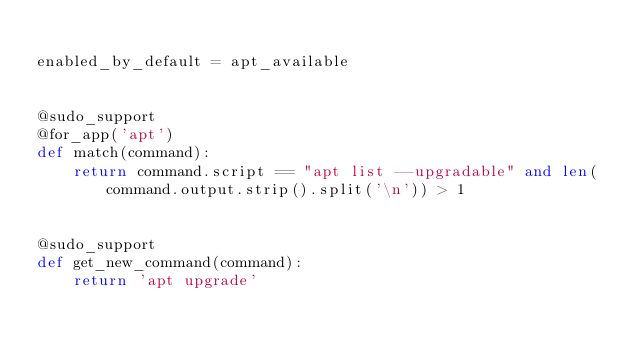<code> <loc_0><loc_0><loc_500><loc_500><_Python_>
enabled_by_default = apt_available


@sudo_support
@for_app('apt')
def match(command):
    return command.script == "apt list --upgradable" and len(command.output.strip().split('\n')) > 1


@sudo_support
def get_new_command(command):
    return 'apt upgrade'
</code> 